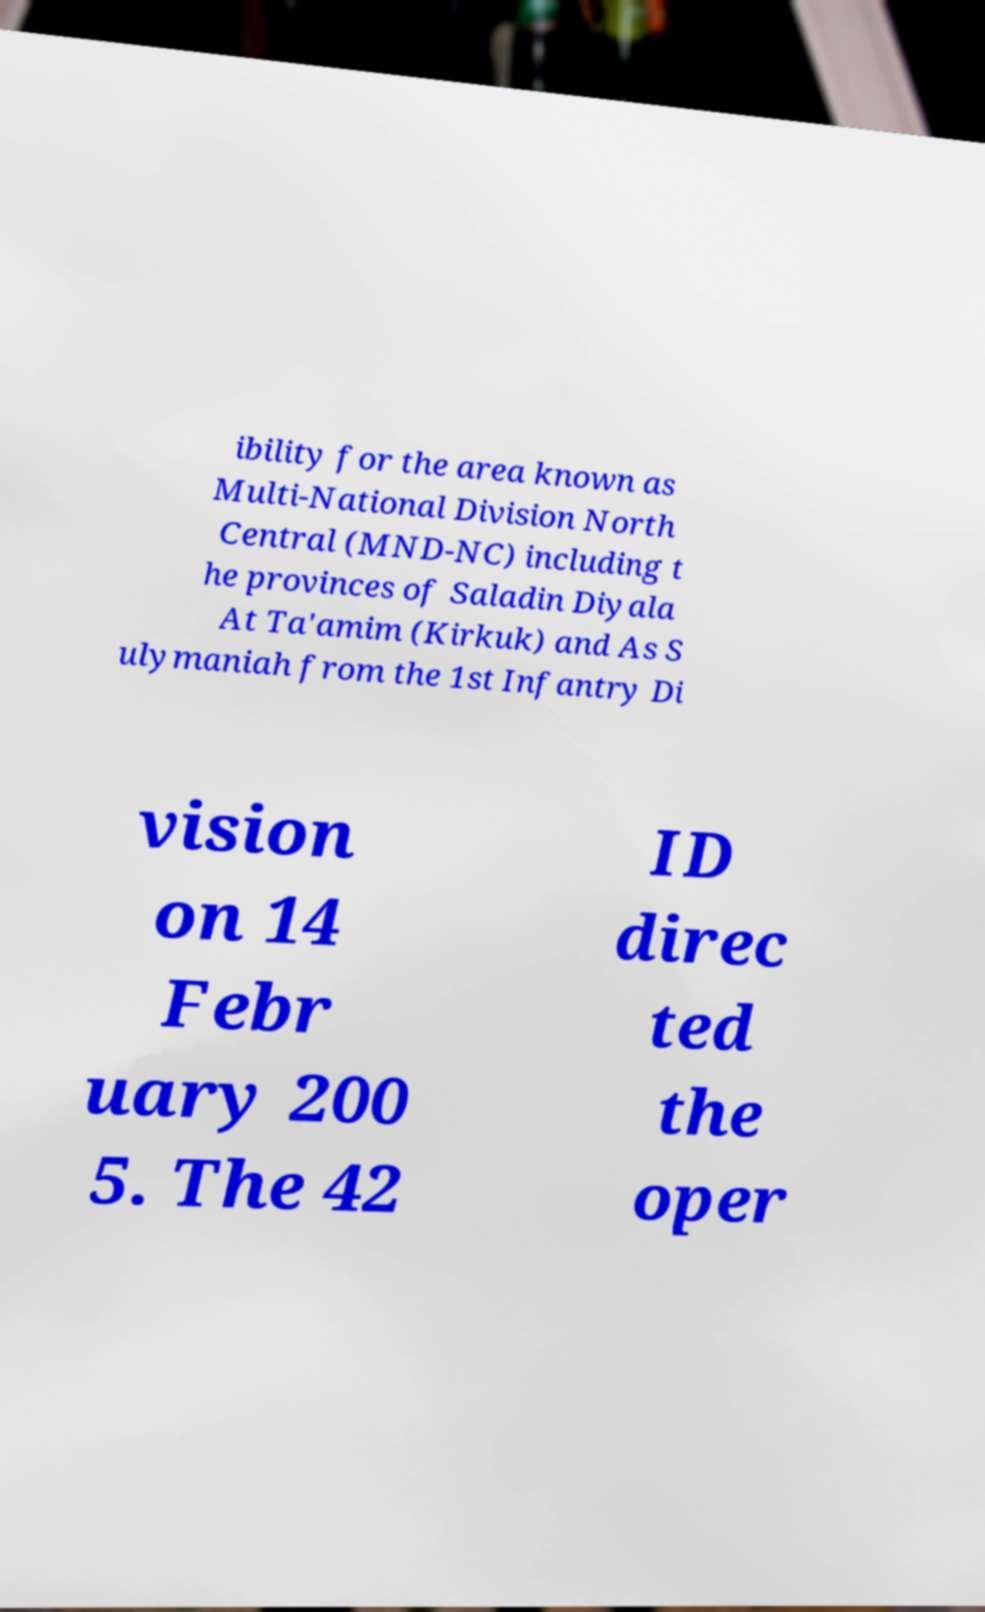Could you assist in decoding the text presented in this image and type it out clearly? ibility for the area known as Multi-National Division North Central (MND-NC) including t he provinces of Saladin Diyala At Ta'amim (Kirkuk) and As S ulymaniah from the 1st Infantry Di vision on 14 Febr uary 200 5. The 42 ID direc ted the oper 